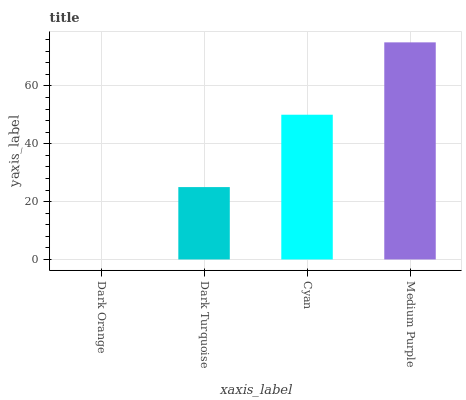Is Dark Orange the minimum?
Answer yes or no. Yes. Is Medium Purple the maximum?
Answer yes or no. Yes. Is Dark Turquoise the minimum?
Answer yes or no. No. Is Dark Turquoise the maximum?
Answer yes or no. No. Is Dark Turquoise greater than Dark Orange?
Answer yes or no. Yes. Is Dark Orange less than Dark Turquoise?
Answer yes or no. Yes. Is Dark Orange greater than Dark Turquoise?
Answer yes or no. No. Is Dark Turquoise less than Dark Orange?
Answer yes or no. No. Is Cyan the high median?
Answer yes or no. Yes. Is Dark Turquoise the low median?
Answer yes or no. Yes. Is Dark Orange the high median?
Answer yes or no. No. Is Cyan the low median?
Answer yes or no. No. 